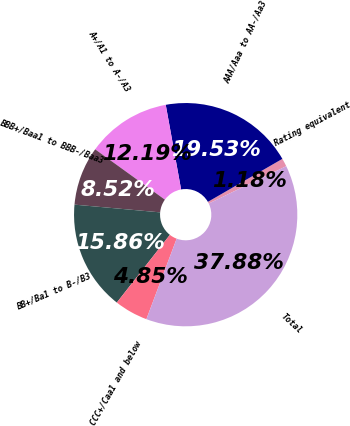Convert chart. <chart><loc_0><loc_0><loc_500><loc_500><pie_chart><fcel>Rating equivalent<fcel>AAA/Aaa to AA-/Aa3<fcel>A+/A1 to A-/A3<fcel>BBB+/Baa1 to BBB-/Baa3<fcel>BB+/Ba1 to B-/B3<fcel>CCC+/Caa1 and below<fcel>Total<nl><fcel>1.18%<fcel>19.53%<fcel>12.19%<fcel>8.52%<fcel>15.86%<fcel>4.85%<fcel>37.88%<nl></chart> 